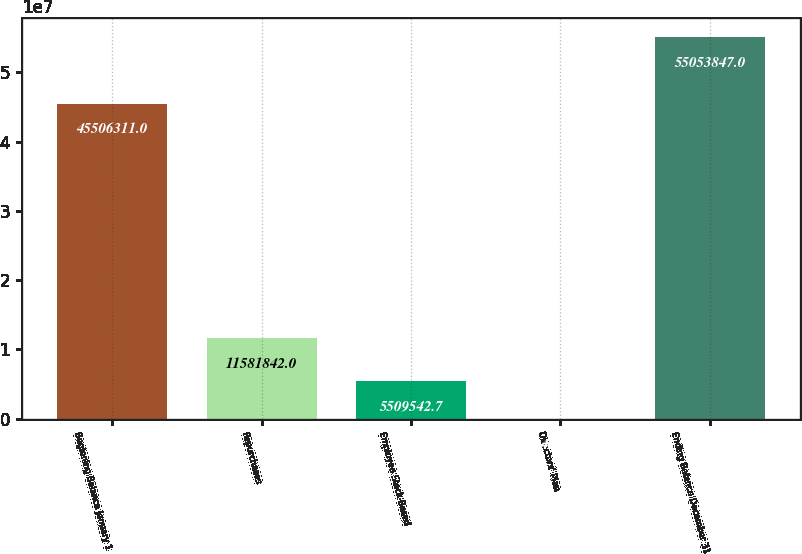<chart> <loc_0><loc_0><loc_500><loc_500><bar_chart><fcel>Beginning Balance January 1<fcel>Repurchases<fcel>Employee Stock-Based<fcel>Directors' Plan<fcel>Ending Balance December 31<nl><fcel>4.55063e+07<fcel>1.15818e+07<fcel>5.50954e+06<fcel>4620<fcel>5.50538e+07<nl></chart> 